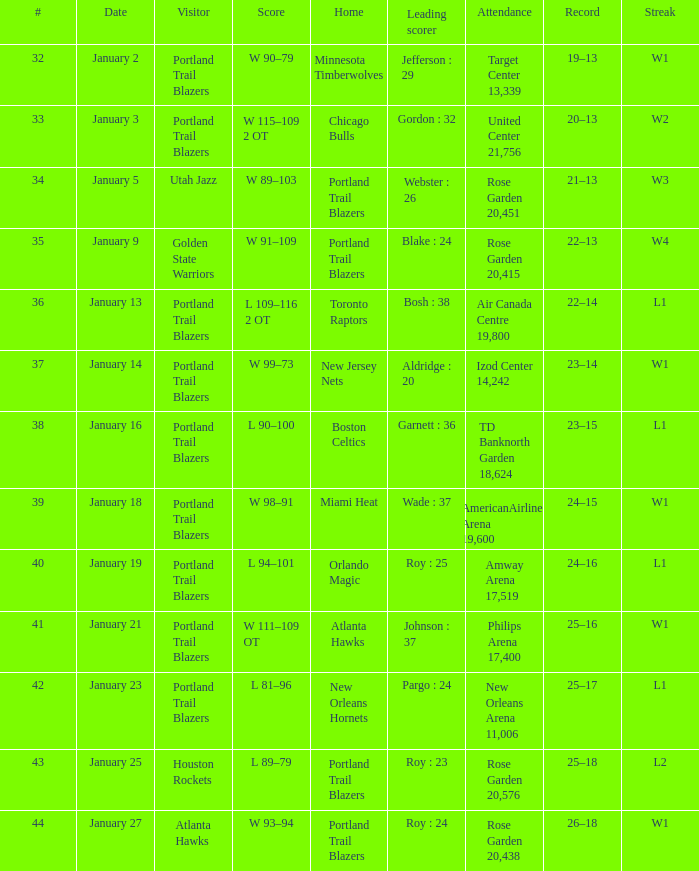Who are all the attendees with a record of 25-18? Houston Rockets. 